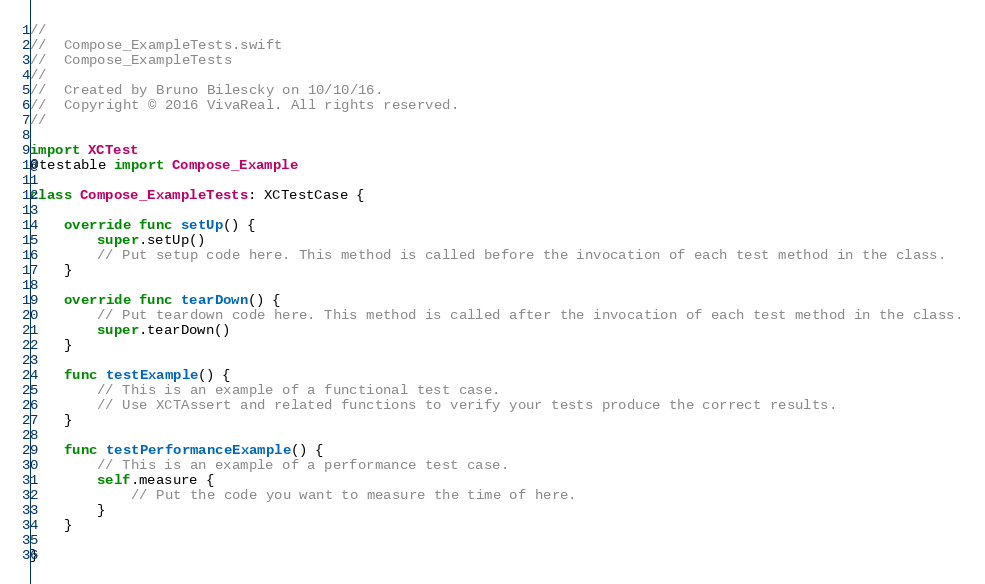<code> <loc_0><loc_0><loc_500><loc_500><_Swift_>//
//  Compose_ExampleTests.swift
//  Compose_ExampleTests
//
//  Created by Bruno Bilescky on 10/10/16.
//  Copyright © 2016 VivaReal. All rights reserved.
//

import XCTest
@testable import Compose_Example

class Compose_ExampleTests: XCTestCase {
    
    override func setUp() {
        super.setUp()
        // Put setup code here. This method is called before the invocation of each test method in the class.
    }
    
    override func tearDown() {
        // Put teardown code here. This method is called after the invocation of each test method in the class.
        super.tearDown()
    }
    
    func testExample() {
        // This is an example of a functional test case.
        // Use XCTAssert and related functions to verify your tests produce the correct results.
    }
    
    func testPerformanceExample() {
        // This is an example of a performance test case.
        self.measure {
            // Put the code you want to measure the time of here.
        }
    }
    
}
</code> 